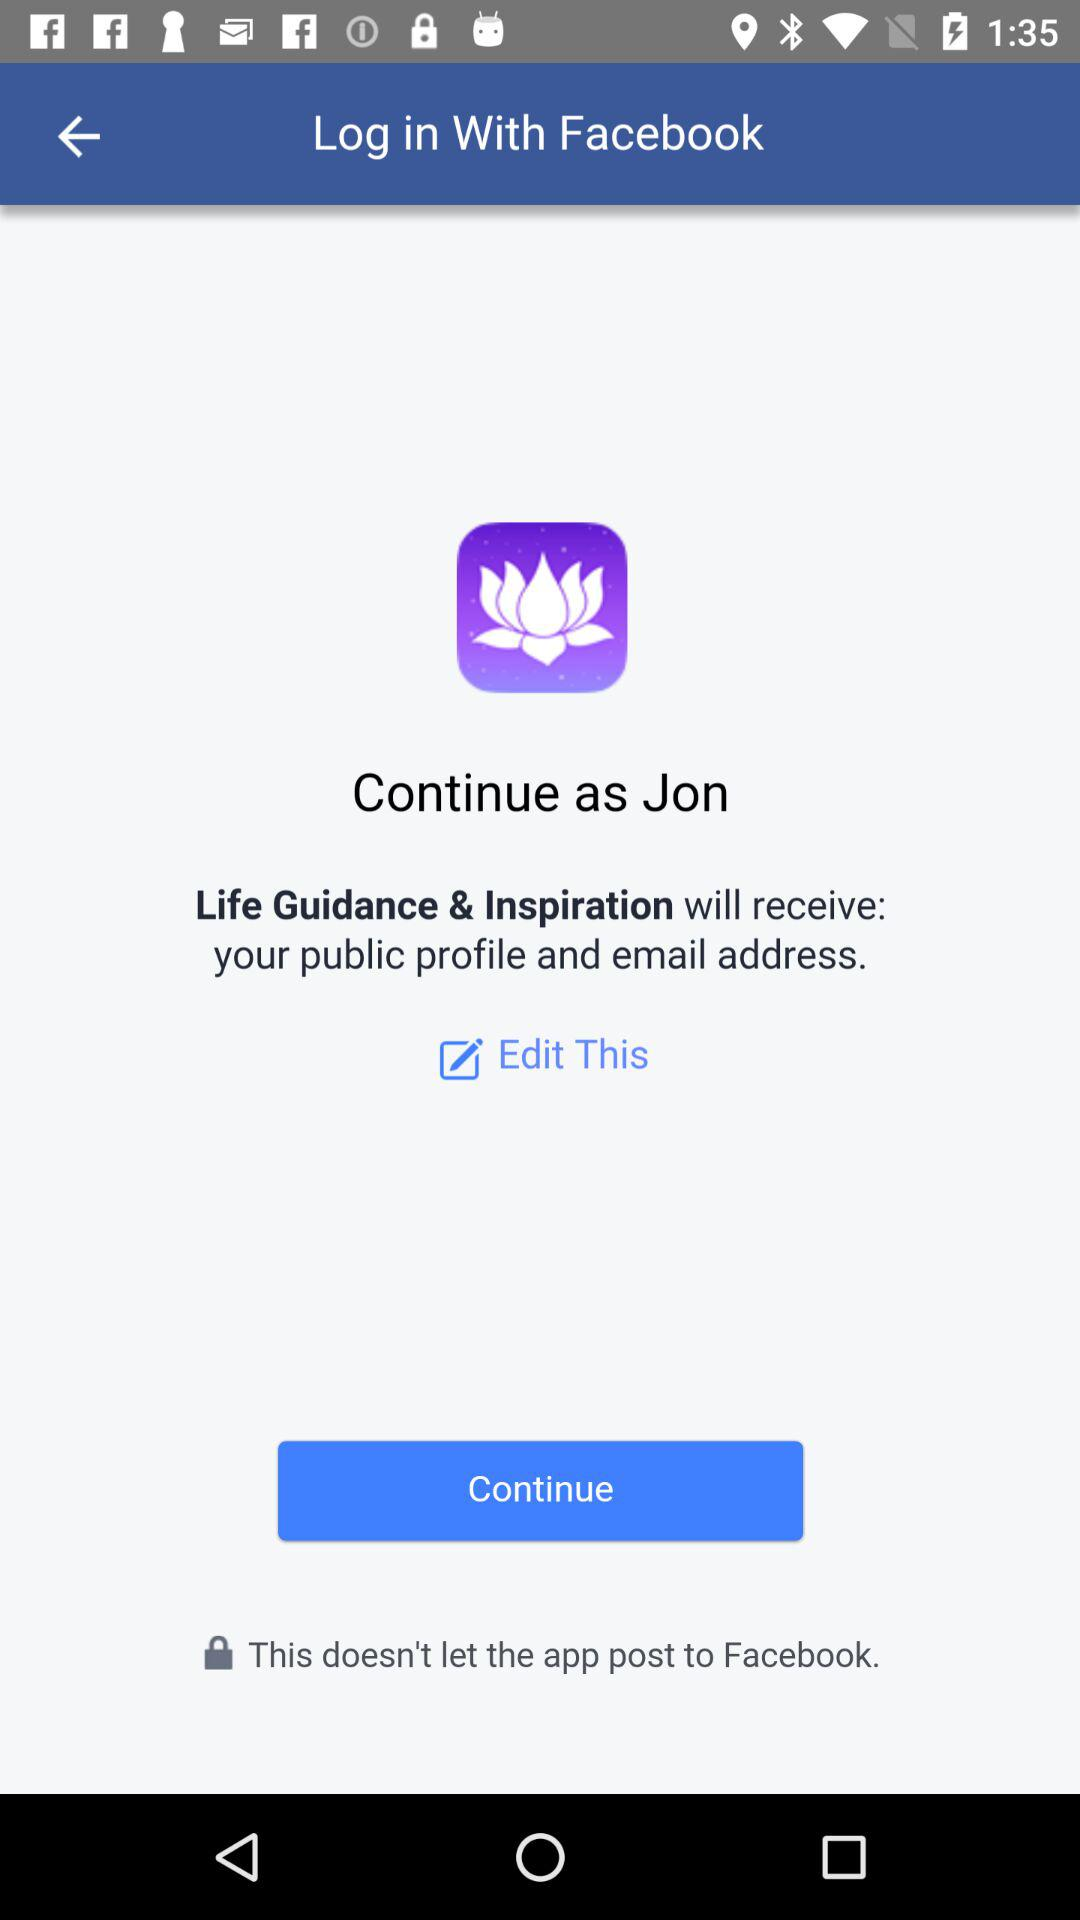What is the name of the user? The user name is Jon. 